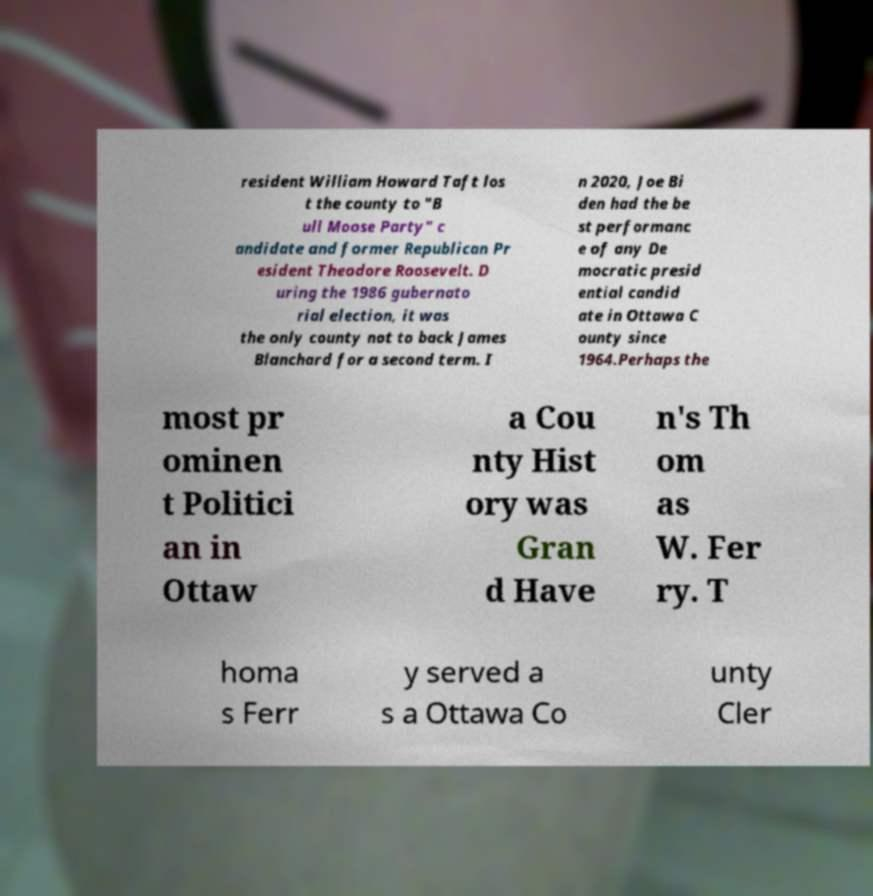Can you read and provide the text displayed in the image?This photo seems to have some interesting text. Can you extract and type it out for me? resident William Howard Taft los t the county to "B ull Moose Party" c andidate and former Republican Pr esident Theodore Roosevelt. D uring the 1986 gubernato rial election, it was the only county not to back James Blanchard for a second term. I n 2020, Joe Bi den had the be st performanc e of any De mocratic presid ential candid ate in Ottawa C ounty since 1964.Perhaps the most pr ominen t Politici an in Ottaw a Cou nty Hist ory was Gran d Have n's Th om as W. Fer ry. T homa s Ferr y served a s a Ottawa Co unty Cler 